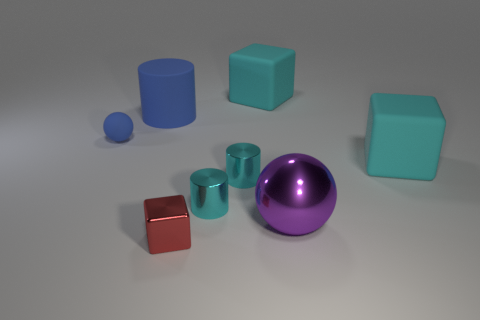Subtract all small cylinders. How many cylinders are left? 1 Subtract 1 cubes. How many cubes are left? 2 Subtract all green cylinders. How many cyan cubes are left? 2 Add 2 large purple shiny cylinders. How many objects exist? 10 Subtract all red cubes. How many cubes are left? 2 Subtract 0 gray cylinders. How many objects are left? 8 Subtract all cylinders. How many objects are left? 5 Subtract all blue cubes. Subtract all green cylinders. How many cubes are left? 3 Subtract all red objects. Subtract all metallic blocks. How many objects are left? 6 Add 8 rubber spheres. How many rubber spheres are left? 9 